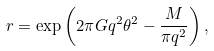<formula> <loc_0><loc_0><loc_500><loc_500>r = \exp \left ( 2 \pi G q ^ { 2 } \theta ^ { 2 } - \frac { M } { \pi q ^ { 2 } } \right ) ,</formula> 